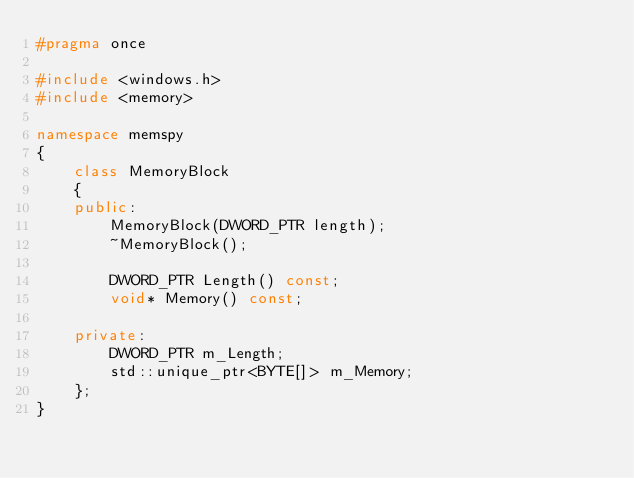Convert code to text. <code><loc_0><loc_0><loc_500><loc_500><_C++_>#pragma once

#include <windows.h>
#include <memory>

namespace memspy
{
	class MemoryBlock
	{
	public:
		MemoryBlock(DWORD_PTR length);
		~MemoryBlock();

		DWORD_PTR Length() const;
		void* Memory() const;

	private:
		DWORD_PTR m_Length;
		std::unique_ptr<BYTE[]> m_Memory;
	};
}</code> 